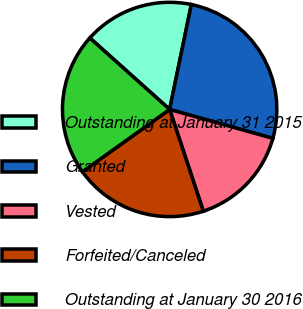Convert chart to OTSL. <chart><loc_0><loc_0><loc_500><loc_500><pie_chart><fcel>Outstanding at January 31 2015<fcel>Granted<fcel>Vested<fcel>Forfeited/Canceled<fcel>Outstanding at January 30 2016<nl><fcel>16.62%<fcel>26.1%<fcel>15.57%<fcel>20.21%<fcel>21.5%<nl></chart> 